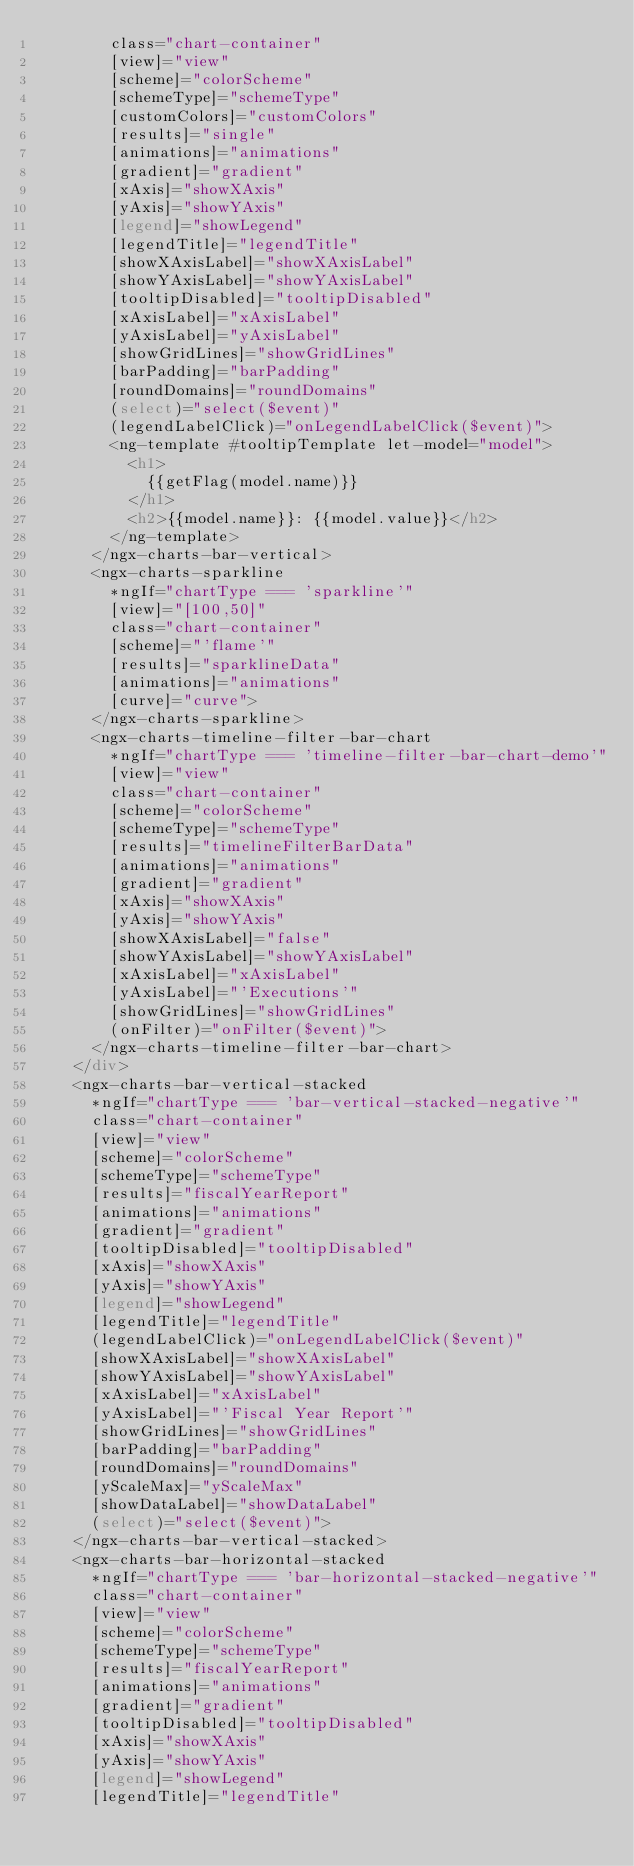Convert code to text. <code><loc_0><loc_0><loc_500><loc_500><_HTML_>        class="chart-container"
        [view]="view"
        [scheme]="colorScheme"
        [schemeType]="schemeType"
        [customColors]="customColors"
        [results]="single"
        [animations]="animations"
        [gradient]="gradient"
        [xAxis]="showXAxis"
        [yAxis]="showYAxis"
        [legend]="showLegend"
        [legendTitle]="legendTitle"
        [showXAxisLabel]="showXAxisLabel"
        [showYAxisLabel]="showYAxisLabel"
        [tooltipDisabled]="tooltipDisabled"
        [xAxisLabel]="xAxisLabel"
        [yAxisLabel]="yAxisLabel"
        [showGridLines]="showGridLines"
        [barPadding]="barPadding"
        [roundDomains]="roundDomains"
        (select)="select($event)"
        (legendLabelClick)="onLegendLabelClick($event)">
        <ng-template #tooltipTemplate let-model="model">
          <h1>
            {{getFlag(model.name)}}
          </h1>
          <h2>{{model.name}}: {{model.value}}</h2>
        </ng-template>
      </ngx-charts-bar-vertical>
      <ngx-charts-sparkline
        *ngIf="chartType === 'sparkline'"
        [view]="[100,50]"
        class="chart-container"
        [scheme]="'flame'"
        [results]="sparklineData"
        [animations]="animations"
        [curve]="curve">
      </ngx-charts-sparkline>
      <ngx-charts-timeline-filter-bar-chart
        *ngIf="chartType === 'timeline-filter-bar-chart-demo'"
        [view]="view"
        class="chart-container"
        [scheme]="colorScheme"
        [schemeType]="schemeType"
        [results]="timelineFilterBarData"
        [animations]="animations"
        [gradient]="gradient"
        [xAxis]="showXAxis"
        [yAxis]="showYAxis"
        [showXAxisLabel]="false"
        [showYAxisLabel]="showYAxisLabel"
        [xAxisLabel]="xAxisLabel"
        [yAxisLabel]="'Executions'"
        [showGridLines]="showGridLines"
        (onFilter)="onFilter($event)">
      </ngx-charts-timeline-filter-bar-chart>
    </div>
    <ngx-charts-bar-vertical-stacked
      *ngIf="chartType === 'bar-vertical-stacked-negative'"
      class="chart-container"
      [view]="view"
      [scheme]="colorScheme"
      [schemeType]="schemeType"
      [results]="fiscalYearReport"
      [animations]="animations"
      [gradient]="gradient"
      [tooltipDisabled]="tooltipDisabled"
      [xAxis]="showXAxis"
      [yAxis]="showYAxis"
      [legend]="showLegend"
      [legendTitle]="legendTitle"
      (legendLabelClick)="onLegendLabelClick($event)"
      [showXAxisLabel]="showXAxisLabel"
      [showYAxisLabel]="showYAxisLabel"
      [xAxisLabel]="xAxisLabel"
      [yAxisLabel]="'Fiscal Year Report'"
      [showGridLines]="showGridLines"
      [barPadding]="barPadding"
      [roundDomains]="roundDomains"
      [yScaleMax]="yScaleMax"
      [showDataLabel]="showDataLabel"
      (select)="select($event)">
    </ngx-charts-bar-vertical-stacked>
    <ngx-charts-bar-horizontal-stacked
      *ngIf="chartType === 'bar-horizontal-stacked-negative'"
      class="chart-container"
      [view]="view"
      [scheme]="colorScheme"
      [schemeType]="schemeType"
      [results]="fiscalYearReport"
      [animations]="animations"
      [gradient]="gradient"
      [tooltipDisabled]="tooltipDisabled"
      [xAxis]="showXAxis"
      [yAxis]="showYAxis"
      [legend]="showLegend"
      [legendTitle]="legendTitle"</code> 